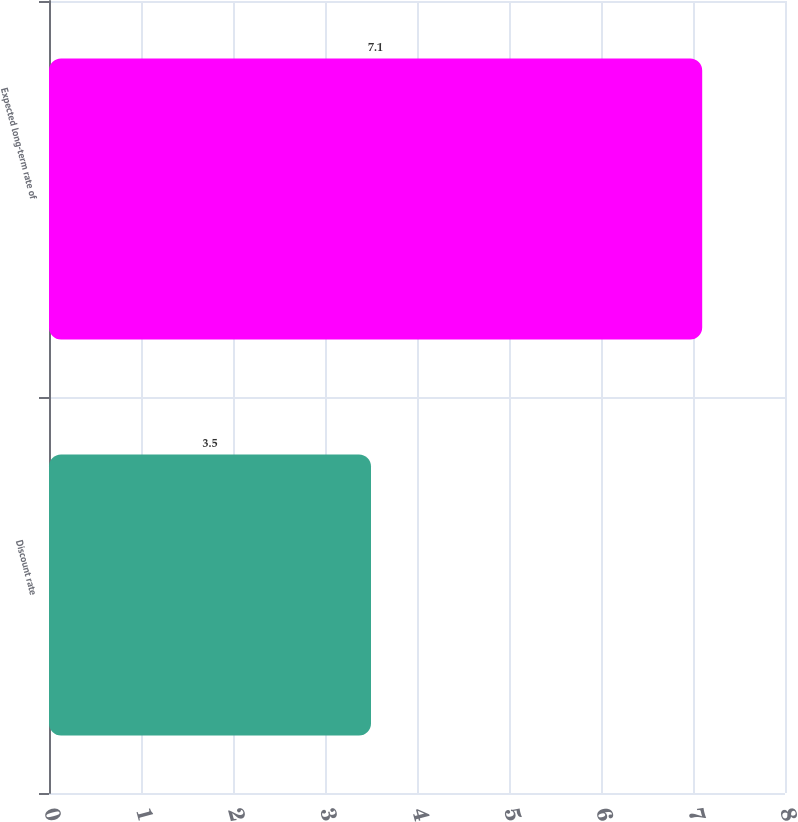<chart> <loc_0><loc_0><loc_500><loc_500><bar_chart><fcel>Discount rate<fcel>Expected long-term rate of<nl><fcel>3.5<fcel>7.1<nl></chart> 